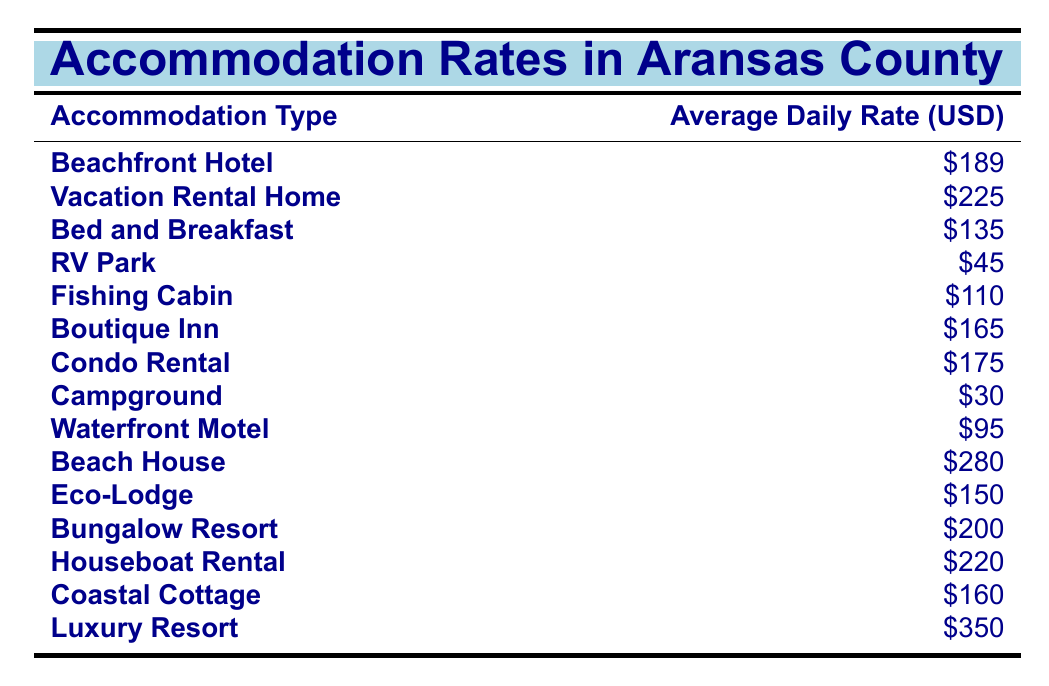What is the average daily rate of a Beachfront Hotel? The table indicates that the average daily rate for a Beachfront Hotel is listed directly in the second column next to its type. The value is \$189.
Answer: 189 Which accommodation type has the highest average daily rate? By scanning the average daily rates in the table, the Luxury Resort has the highest rate listed, which is \$350.
Answer: 350 What is the average daily rate of RV Park and Campground combined? The average daily rate for RV Park is \$45 and for Campground is \$30. Adding these rates gives \$45 + \$30 = \$75.
Answer: 75 Is the average daily rate of a Fishing Cabin higher than that of a Waterfront Motel? The Fishing Cabin has an average daily rate of \$110, while the Waterfront Motel has a rate of \$95. Since \$110 is greater than \$95, the statement is true.
Answer: True What is the difference between the average daily rates of a Beach House and a Bed and Breakfast? The average daily rate for a Beach House is \$280 and for a Bed and Breakfast, it is \$135. To find the difference, subtract \$135 from \$280: \$280 - \$135 = \$145.
Answer: 145 What is the average daily rate of all accommodations listed in the table? First, sum all the average daily rates: 189 + 225 + 135 + 45 + 110 + 165 + 175 + 30 + 95 + 280 + 150 + 200 + 220 + 160 + 350 = 2,540. Then, divide this sum by the number of accommodations (15): 2,540 / 15 = 169.33.
Answer: 169.33 Which accommodation types have an average daily rate below \$100? By checking the rates, the RV Park (\$45), Campground (\$30), and Waterfront Motel (\$95) all have rates under \$100. Therefore, the accommodation types are RV Park, Campground, and Waterfront Motel.
Answer: RV Park, Campground, Waterfront Motel How many accommodation types have an average daily rate greater than \$200? The table shows that the accommodations with rates greater than \$200 are Beach House (\$280) and Luxury Resort (\$350). This indicates there are 2 such types.
Answer: 2 If a visitor stays 3 nights in a Condo Rental, how much will it cost? The average daily rate for a Condo Rental is \$175. To find the 3-night cost, multiply the rate by the number of nights: \$175 x 3 = \$525.
Answer: 525 Is there any accommodation type with an average daily rate between \$150 and \$200? Upon reviewing the table, the Eco-Lodge (\$150), Coastal Cottage (\$160), Boutique Inn (\$165), and Bungalow Resort (\$200) all fall within this range. Therefore, the answer is true.
Answer: True 